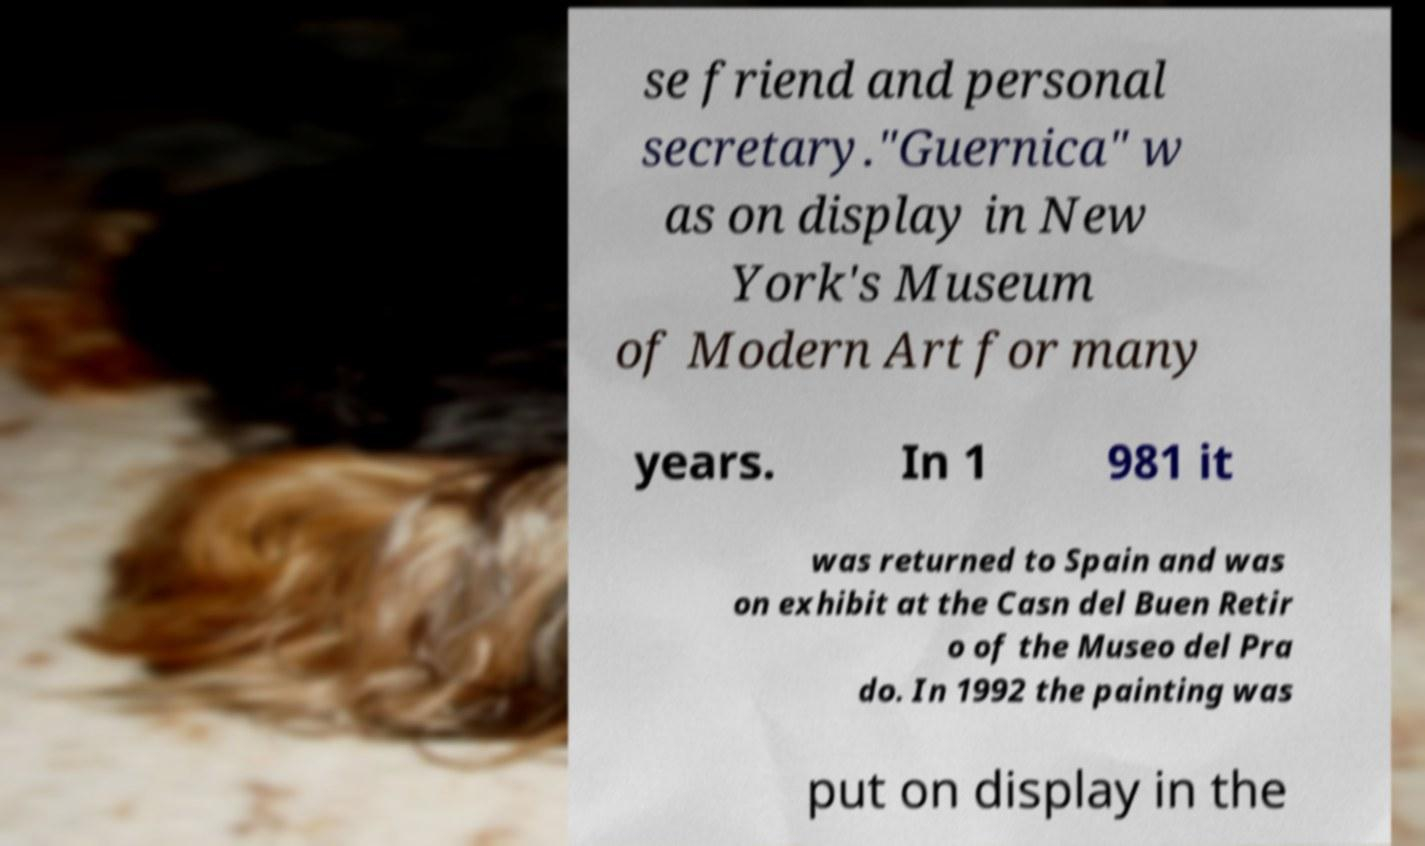I need the written content from this picture converted into text. Can you do that? se friend and personal secretary."Guernica" w as on display in New York's Museum of Modern Art for many years. In 1 981 it was returned to Spain and was on exhibit at the Casn del Buen Retir o of the Museo del Pra do. In 1992 the painting was put on display in the 